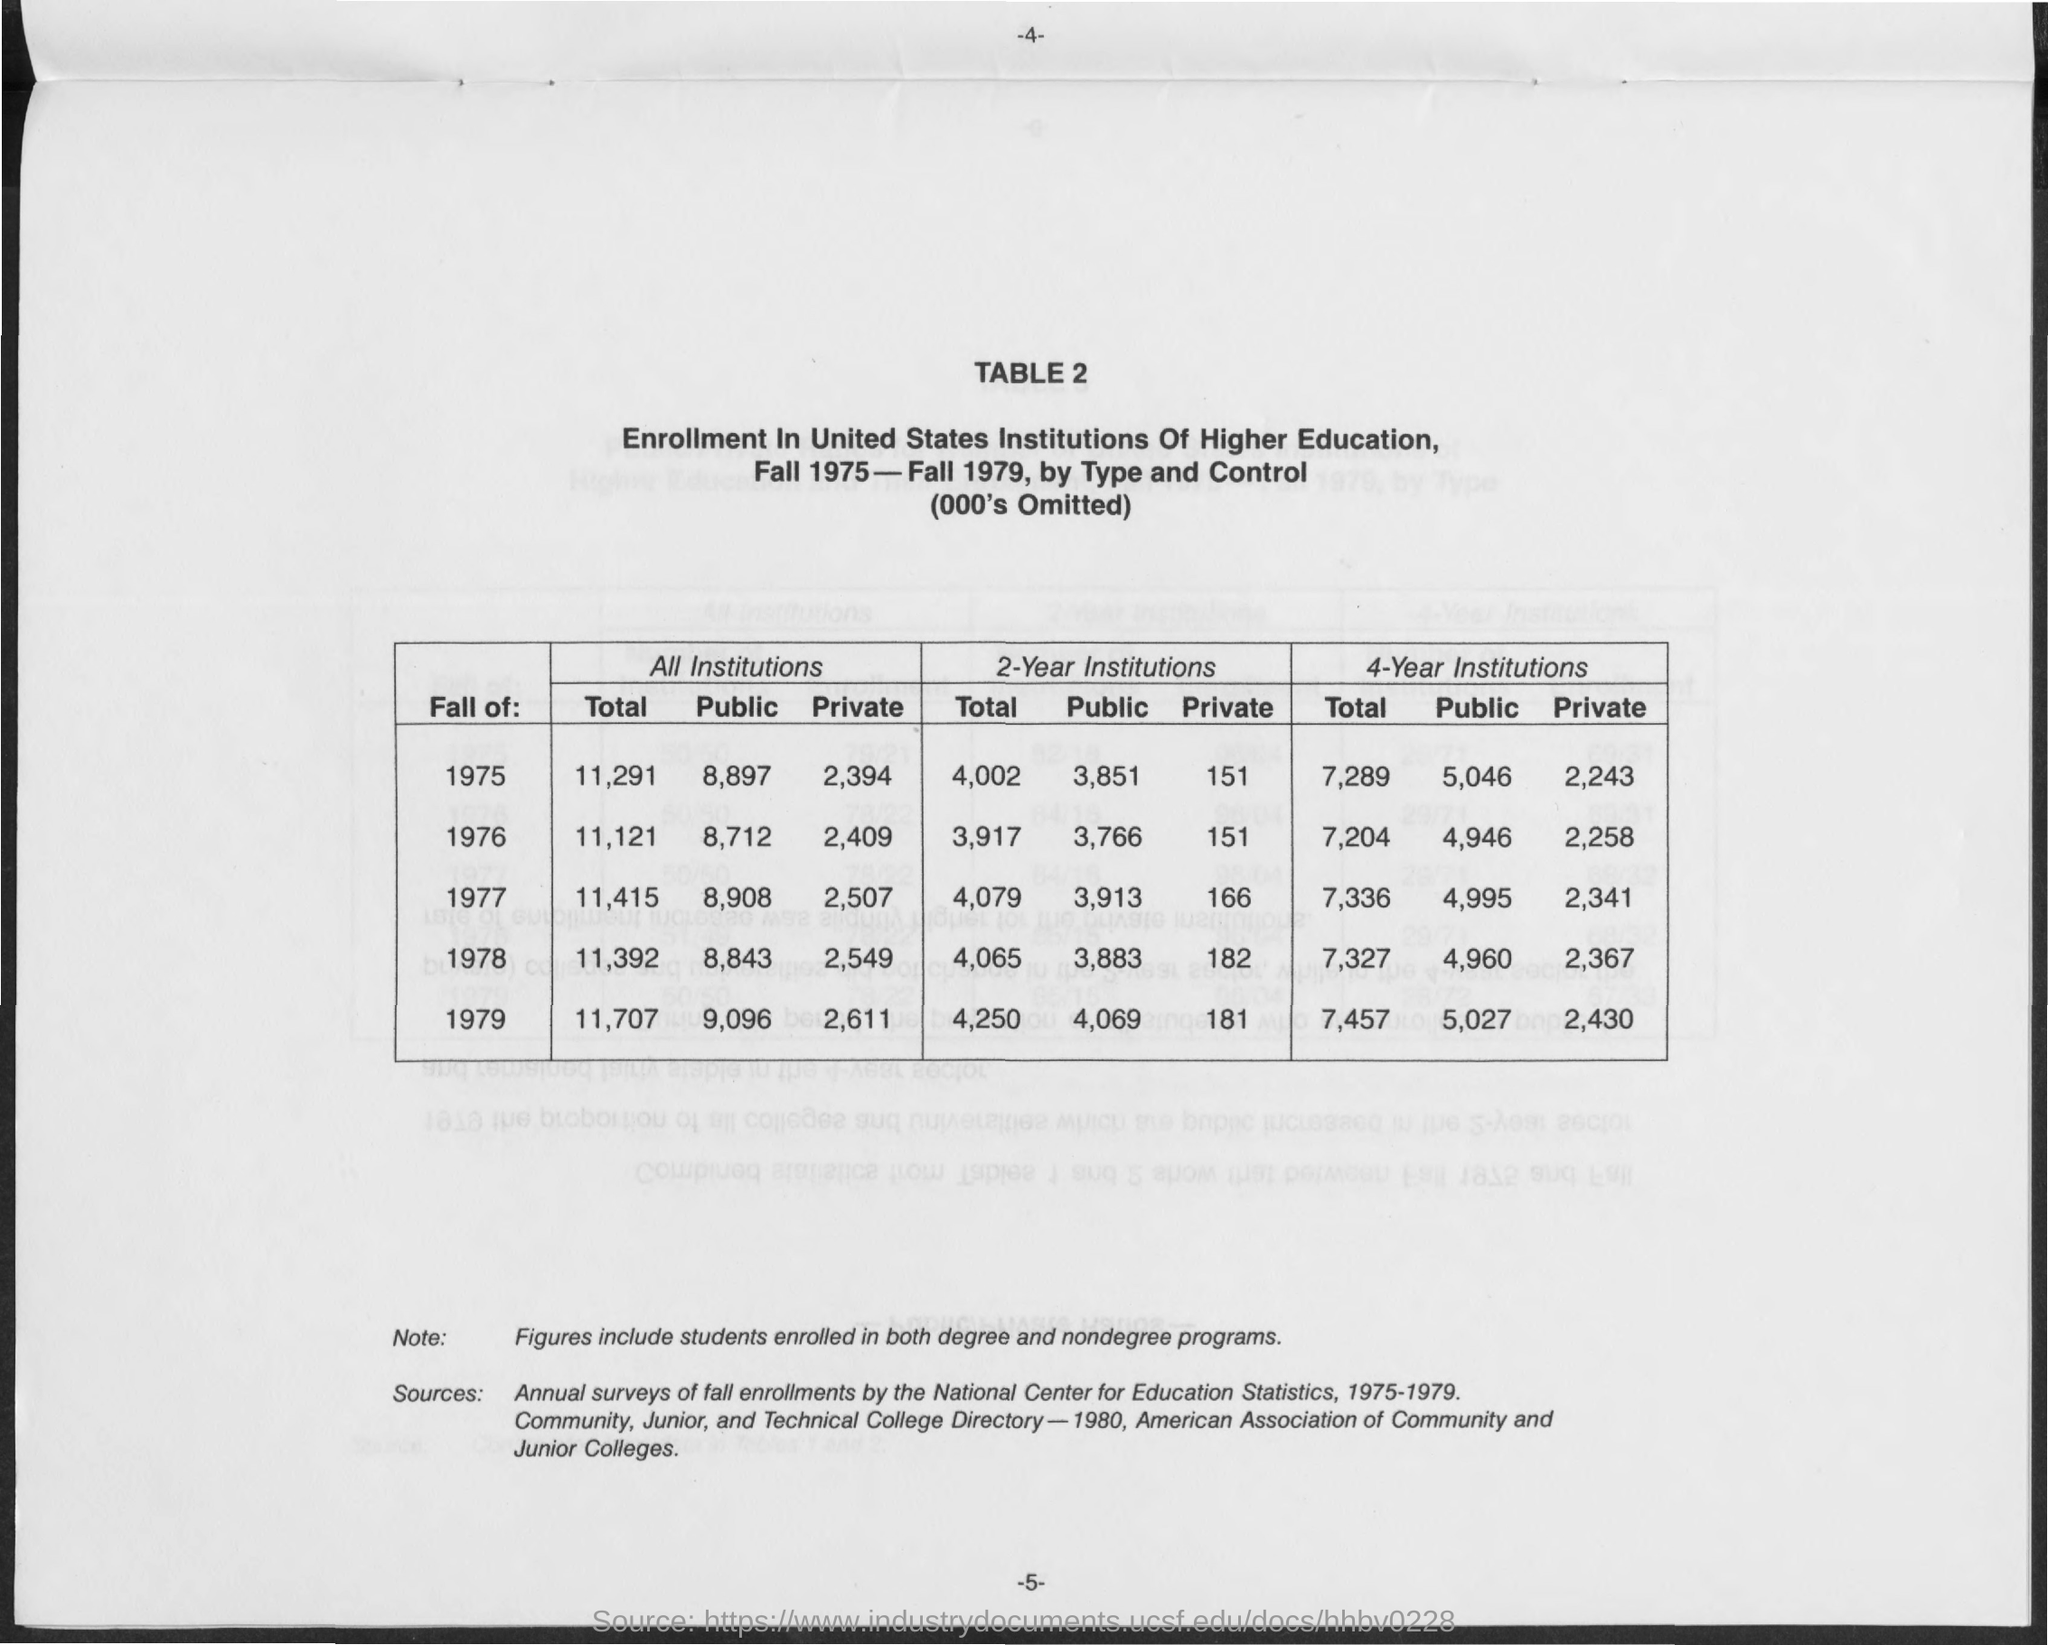Point out several critical features in this image. The total enrollment in all institutions during the fall of 1977 was 11,415. The total enrollment in all institutions during the fall of 1979 was 11,707. During the Fall of 1975, the public enrollment in all institutions totaled 8,897. During the fall of 1979, the public enrollment in all institutions was 9,096. During the fall of 1978, the public enrollment in all institutions was 8,843. 